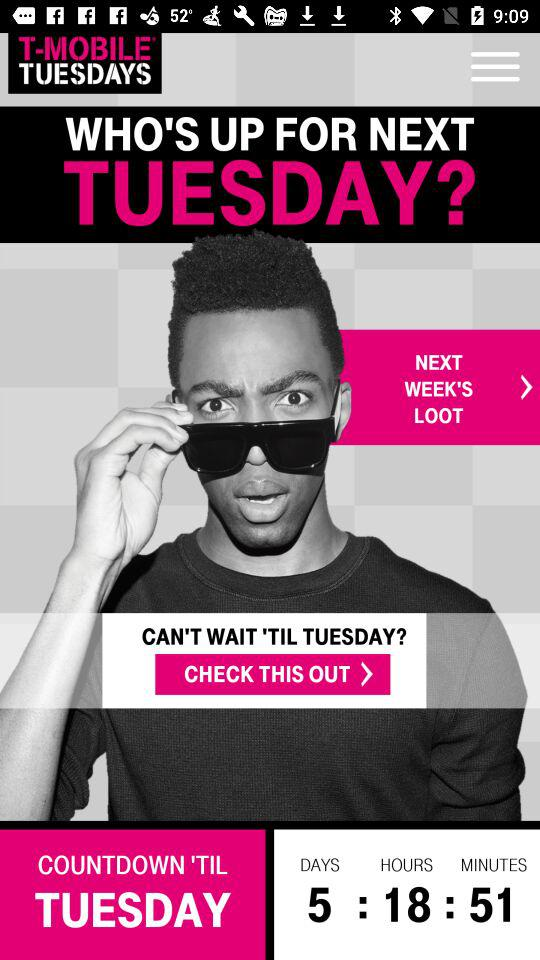How many days are left till Tuesday on the countdown? There are 5 days left. 